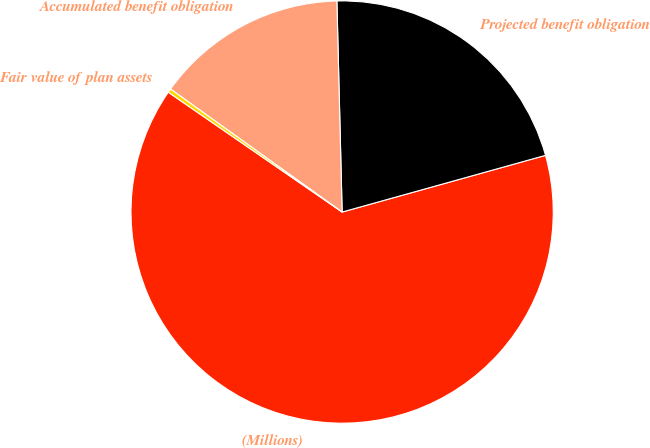<chart> <loc_0><loc_0><loc_500><loc_500><pie_chart><fcel>(Millions)<fcel>Projected benefit obligation<fcel>Accumulated benefit obligation<fcel>Fair value of plan assets<nl><fcel>63.94%<fcel>21.07%<fcel>14.71%<fcel>0.29%<nl></chart> 